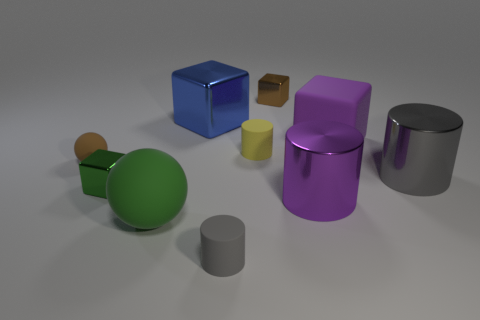How many metal objects are in front of the big gray object and to the left of the brown shiny block?
Give a very brief answer. 1. How many green cubes are left of the tiny metallic block that is on the left side of the brown metal cube?
Keep it short and to the point. 0. There is a cylinder that is behind the small brown rubber sphere; is it the same size as the purple thing that is on the left side of the big purple rubber block?
Your response must be concise. No. What number of brown things are there?
Offer a terse response. 2. How many cubes have the same material as the blue object?
Your answer should be very brief. 2. Are there the same number of metal blocks that are on the right side of the gray matte cylinder and blue shiny things?
Provide a succinct answer. Yes. There is a object that is the same color as the small ball; what is its material?
Your answer should be very brief. Metal. There is a green sphere; is its size the same as the gray metal cylinder on the right side of the large blue object?
Make the answer very short. Yes. What number of other objects are there of the same size as the green rubber sphere?
Give a very brief answer. 4. What number of other objects are there of the same color as the large matte sphere?
Offer a very short reply. 1. 